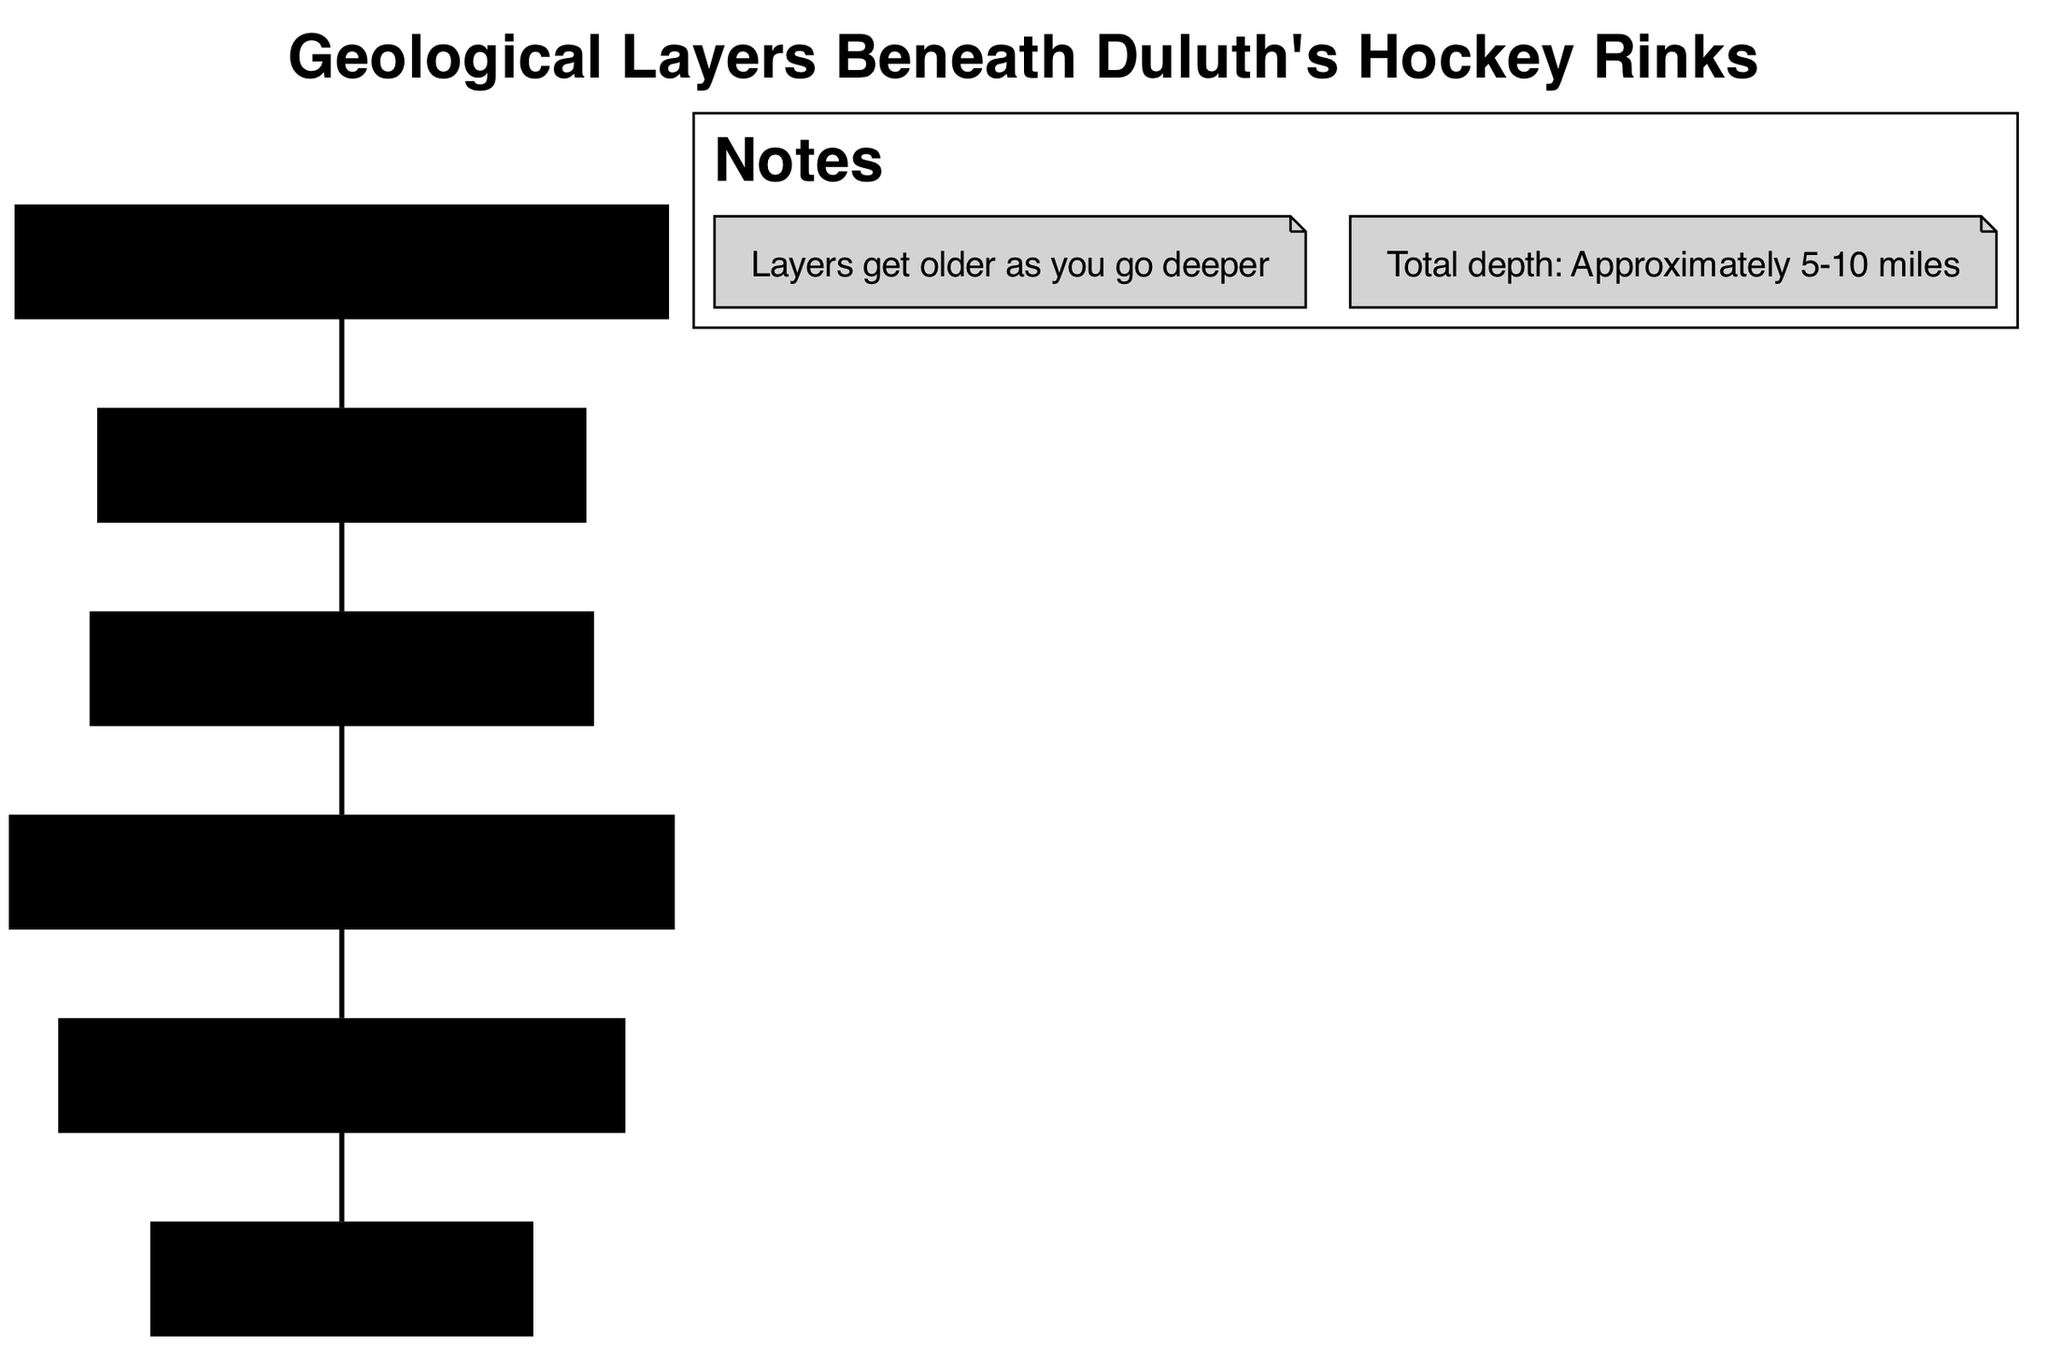What is the uppermost layer in the geological diagram? The uppermost layer is specified in the data as "Surface," which directly correlates to the layer that contains ice rinks and arenas.
Answer: Surface What percentage of the total depth does the Archean Basement represent? The diagram describes that layers get older as you go deeper, and the Archean Basement is the deepest layer mentioned, which suggests it represents the full depth of approximately 5-10 miles. However, without specific proportion data, the answer remains general.
Answer: Deepest layer Which layer contains iron-rich sedimentary rocks? According to the layer descriptions, the "Biwabik Iron Formation" is explicitly named as containing iron-rich sedimentary rocks.
Answer: Biwabik Iron Formation How many layers are there in total? The data lists 6 distinct layers beneath Duluth, including surface structures and rock formations. Counting them directly yields the total.
Answer: 6 What does the Duluth Complex mainly consist of? The Duluth Complex is described as composed of igneous rocks that are rich in copper and nickel, directly providing insights into the composition of that layer.
Answer: Copper and nickel Which layer is the second oldest in the geological structure? Assessing the relationship between layers, the second oldest layer can be identified by counting upward from the bottom where the Archean Basement is the oldest, making the "North Shore Volcanic Group" the second oldest.
Answer: North Shore Volcanic Group What is the composition of the Glacial Till layer? The data specifically describes Glacial Till as a mixture of clay, sand, and gravel, indicating its composition directly as noted in the diagram.
Answer: Mixture of clay, sand, and gravel What type of rock is found in the North Shore Volcanic Group? The North Shore Volcanic Group is characterized in the description as consisting of ancient lava flows, denoting the type of rock formation present in that layer.
Answer: Lava flows Which layer is closest to the surface? The "Surface" layer, which hosts ice rinks and arenas, is identified as the closest layer to the ground based on the description given in the data.
Answer: Surface 